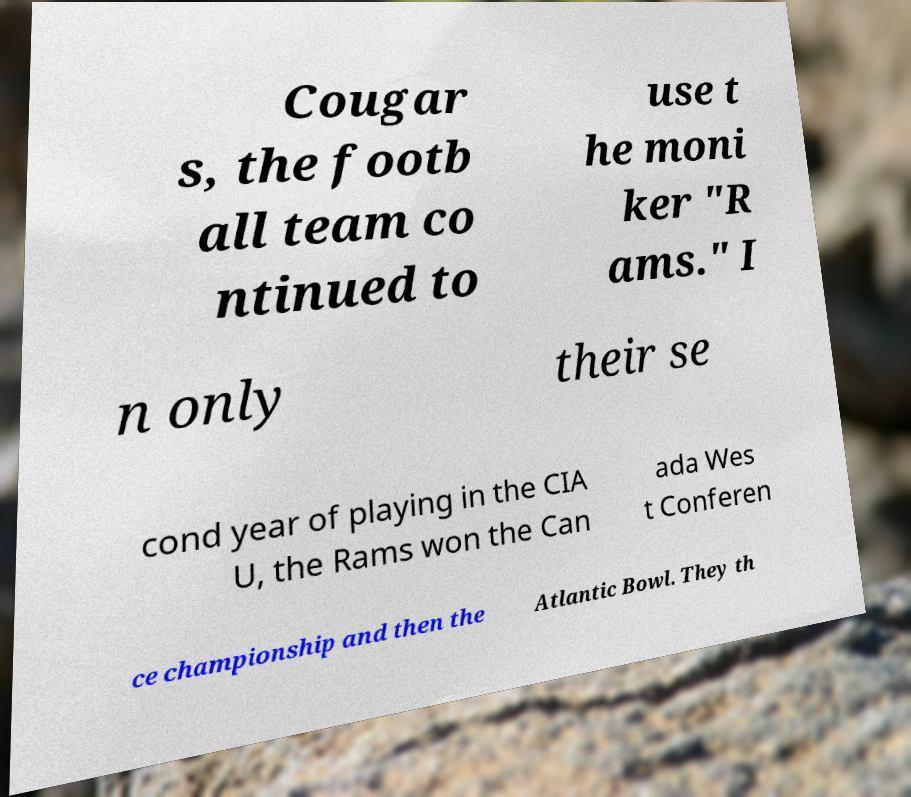Could you assist in decoding the text presented in this image and type it out clearly? Cougar s, the footb all team co ntinued to use t he moni ker "R ams." I n only their se cond year of playing in the CIA U, the Rams won the Can ada Wes t Conferen ce championship and then the Atlantic Bowl. They th 